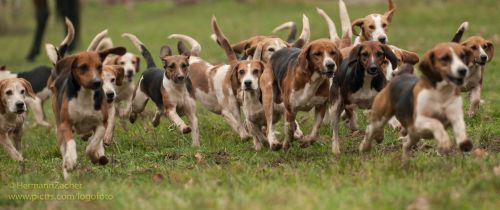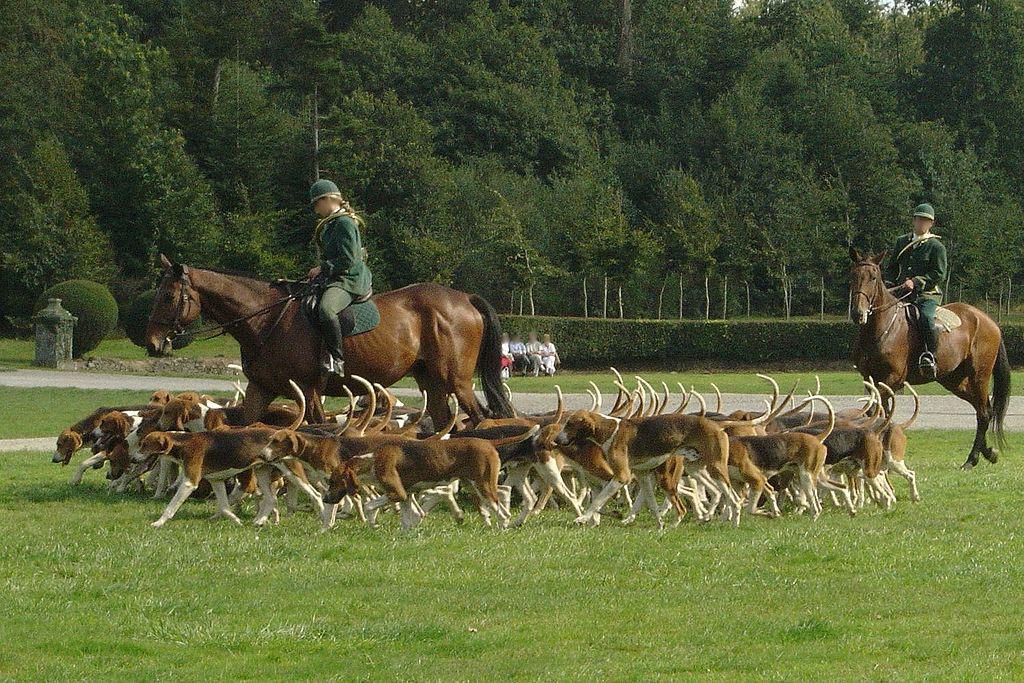The first image is the image on the left, the second image is the image on the right. Given the left and right images, does the statement "There is one person standing in the image on the right." hold true? Answer yes or no. No. The first image is the image on the left, the second image is the image on the right. Examine the images to the left and right. Is the description "There is a person standing among several dogs in the image on the right." accurate? Answer yes or no. No. 